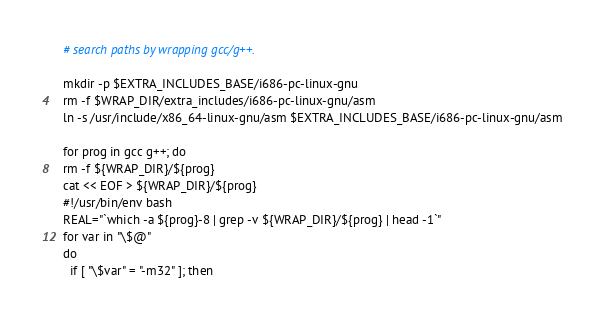<code> <loc_0><loc_0><loc_500><loc_500><_YAML_>  # search paths by wrapping gcc/g++.

  mkdir -p $EXTRA_INCLUDES_BASE/i686-pc-linux-gnu
  rm -f $WRAP_DIR/extra_includes/i686-pc-linux-gnu/asm
  ln -s /usr/include/x86_64-linux-gnu/asm $EXTRA_INCLUDES_BASE/i686-pc-linux-gnu/asm

  for prog in gcc g++; do
  rm -f ${WRAP_DIR}/${prog}
  cat << EOF > ${WRAP_DIR}/${prog}
  #!/usr/bin/env bash
  REAL="`which -a ${prog}-8 | grep -v ${WRAP_DIR}/${prog} | head -1`"
  for var in "\$@"
  do
    if [ "\$var" = "-m32" ]; then</code> 